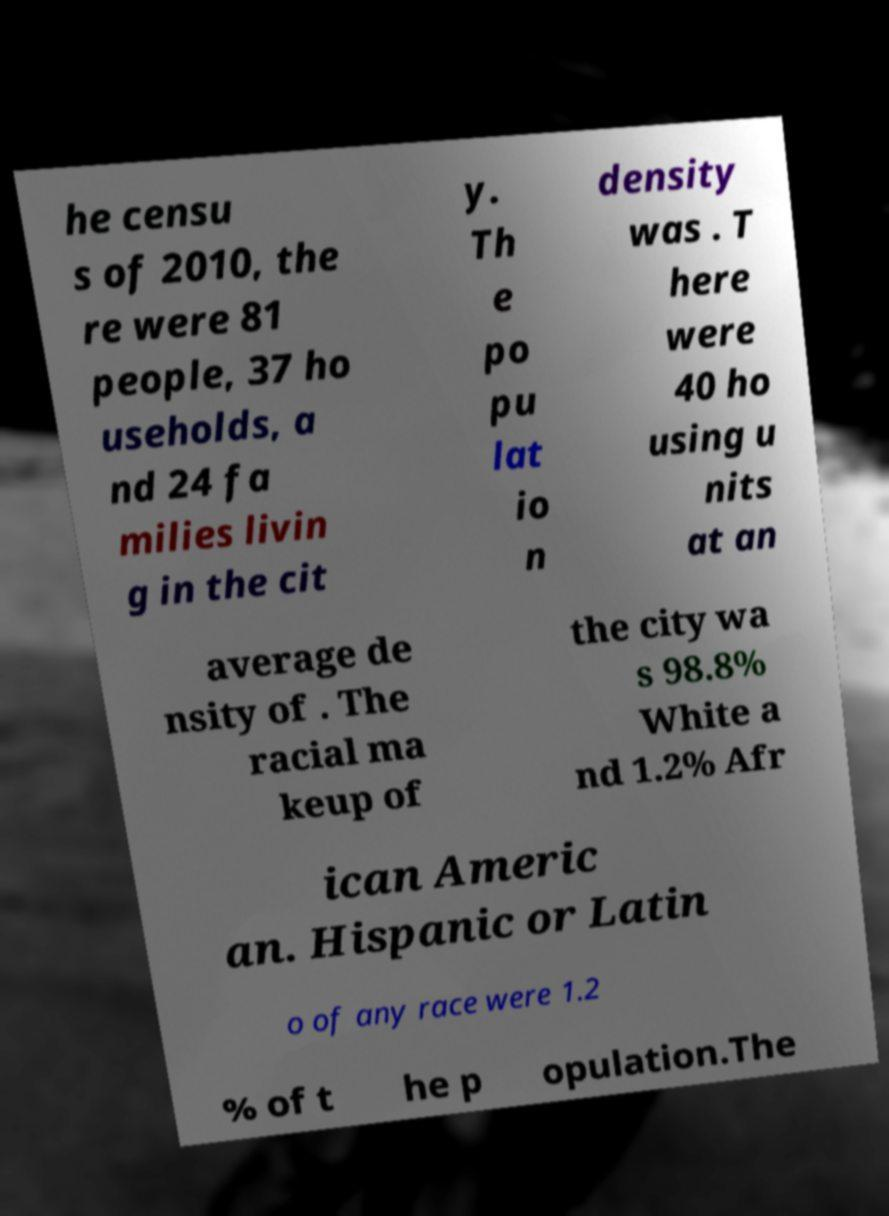What messages or text are displayed in this image? I need them in a readable, typed format. he censu s of 2010, the re were 81 people, 37 ho useholds, a nd 24 fa milies livin g in the cit y. Th e po pu lat io n density was . T here were 40 ho using u nits at an average de nsity of . The racial ma keup of the city wa s 98.8% White a nd 1.2% Afr ican Americ an. Hispanic or Latin o of any race were 1.2 % of t he p opulation.The 